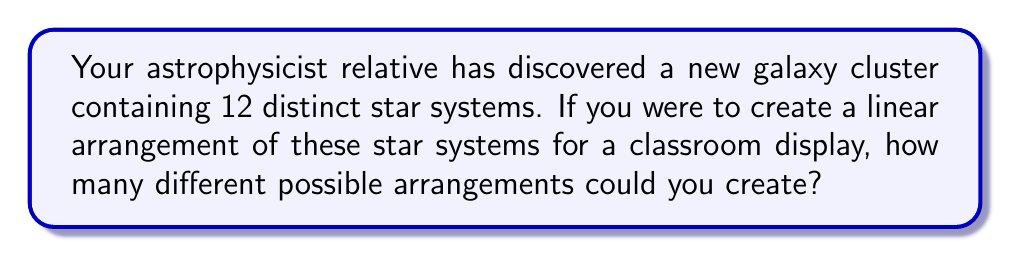Provide a solution to this math problem. Let's approach this step-by-step:

1) This problem is a straightforward application of permutations. We are arranging all 12 star systems in a line, where the order matters.

2) In permutation problems, when we are arranging all n distinct objects, the number of permutations is given by n!

3) In this case, n = 12 (the number of star systems)

4) Therefore, the number of possible arrangements is:

   $$12! = 12 \times 11 \times 10 \times 9 \times 8 \times 7 \times 6 \times 5 \times 4 \times 3 \times 2 \times 1$$

5) Let's calculate this:

   $$12! = 479,001,600$$

This means there are 479,001,600 different ways to arrange these 12 star systems in a line.

As a science teacher, you could use this to demonstrate the vast number of possibilities in astronomical arrangements, even with a relatively small number of objects. This could lead to discussions about the complexity and diversity of the universe.
Answer: $479,001,600$ 